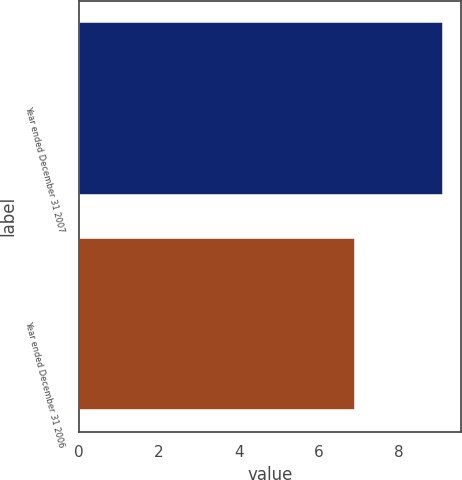Convert chart to OTSL. <chart><loc_0><loc_0><loc_500><loc_500><bar_chart><fcel>Year ended December 31 2007<fcel>Year ended December 31 2006<nl><fcel>9.1<fcel>6.9<nl></chart> 